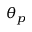<formula> <loc_0><loc_0><loc_500><loc_500>\theta _ { p }</formula> 